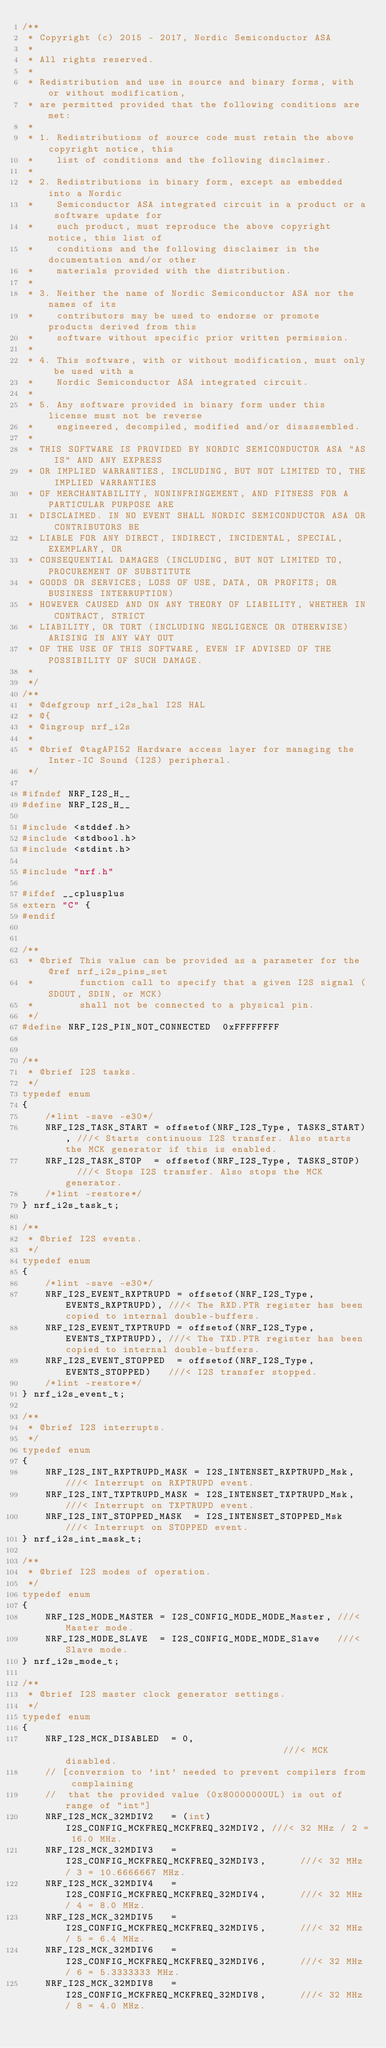Convert code to text. <code><loc_0><loc_0><loc_500><loc_500><_C_>/**
 * Copyright (c) 2015 - 2017, Nordic Semiconductor ASA
 *
 * All rights reserved.
 *
 * Redistribution and use in source and binary forms, with or without modification,
 * are permitted provided that the following conditions are met:
 *
 * 1. Redistributions of source code must retain the above copyright notice, this
 *    list of conditions and the following disclaimer.
 *
 * 2. Redistributions in binary form, except as embedded into a Nordic
 *    Semiconductor ASA integrated circuit in a product or a software update for
 *    such product, must reproduce the above copyright notice, this list of
 *    conditions and the following disclaimer in the documentation and/or other
 *    materials provided with the distribution.
 *
 * 3. Neither the name of Nordic Semiconductor ASA nor the names of its
 *    contributors may be used to endorse or promote products derived from this
 *    software without specific prior written permission.
 *
 * 4. This software, with or without modification, must only be used with a
 *    Nordic Semiconductor ASA integrated circuit.
 *
 * 5. Any software provided in binary form under this license must not be reverse
 *    engineered, decompiled, modified and/or disassembled.
 *
 * THIS SOFTWARE IS PROVIDED BY NORDIC SEMICONDUCTOR ASA "AS IS" AND ANY EXPRESS
 * OR IMPLIED WARRANTIES, INCLUDING, BUT NOT LIMITED TO, THE IMPLIED WARRANTIES
 * OF MERCHANTABILITY, NONINFRINGEMENT, AND FITNESS FOR A PARTICULAR PURPOSE ARE
 * DISCLAIMED. IN NO EVENT SHALL NORDIC SEMICONDUCTOR ASA OR CONTRIBUTORS BE
 * LIABLE FOR ANY DIRECT, INDIRECT, INCIDENTAL, SPECIAL, EXEMPLARY, OR
 * CONSEQUENTIAL DAMAGES (INCLUDING, BUT NOT LIMITED TO, PROCUREMENT OF SUBSTITUTE
 * GOODS OR SERVICES; LOSS OF USE, DATA, OR PROFITS; OR BUSINESS INTERRUPTION)
 * HOWEVER CAUSED AND ON ANY THEORY OF LIABILITY, WHETHER IN CONTRACT, STRICT
 * LIABILITY, OR TORT (INCLUDING NEGLIGENCE OR OTHERWISE) ARISING IN ANY WAY OUT
 * OF THE USE OF THIS SOFTWARE, EVEN IF ADVISED OF THE POSSIBILITY OF SUCH DAMAGE.
 *
 */
/**
 * @defgroup nrf_i2s_hal I2S HAL
 * @{
 * @ingroup nrf_i2s
 *
 * @brief @tagAPI52 Hardware access layer for managing the Inter-IC Sound (I2S) peripheral.
 */

#ifndef NRF_I2S_H__
#define NRF_I2S_H__

#include <stddef.h>
#include <stdbool.h>
#include <stdint.h>

#include "nrf.h"

#ifdef __cplusplus
extern "C" {
#endif


/**
 * @brief This value can be provided as a parameter for the @ref nrf_i2s_pins_set
 *        function call to specify that a given I2S signal (SDOUT, SDIN, or MCK)
 *        shall not be connected to a physical pin.
 */
#define NRF_I2S_PIN_NOT_CONNECTED  0xFFFFFFFF


/**
 * @brief I2S tasks.
 */
typedef enum
{
    /*lint -save -e30*/
    NRF_I2S_TASK_START = offsetof(NRF_I2S_Type, TASKS_START), ///< Starts continuous I2S transfer. Also starts the MCK generator if this is enabled.
    NRF_I2S_TASK_STOP  = offsetof(NRF_I2S_Type, TASKS_STOP)   ///< Stops I2S transfer. Also stops the MCK generator.
    /*lint -restore*/
} nrf_i2s_task_t;

/**
 * @brief I2S events.
 */
typedef enum
{
    /*lint -save -e30*/
    NRF_I2S_EVENT_RXPTRUPD = offsetof(NRF_I2S_Type, EVENTS_RXPTRUPD), ///< The RXD.PTR register has been copied to internal double-buffers.
    NRF_I2S_EVENT_TXPTRUPD = offsetof(NRF_I2S_Type, EVENTS_TXPTRUPD), ///< The TXD.PTR register has been copied to internal double-buffers.
    NRF_I2S_EVENT_STOPPED  = offsetof(NRF_I2S_Type, EVENTS_STOPPED)   ///< I2S transfer stopped.
    /*lint -restore*/
} nrf_i2s_event_t;

/**
 * @brief I2S interrupts.
 */
typedef enum
{
    NRF_I2S_INT_RXPTRUPD_MASK = I2S_INTENSET_RXPTRUPD_Msk, ///< Interrupt on RXPTRUPD event.
    NRF_I2S_INT_TXPTRUPD_MASK = I2S_INTENSET_TXPTRUPD_Msk, ///< Interrupt on TXPTRUPD event.
    NRF_I2S_INT_STOPPED_MASK  = I2S_INTENSET_STOPPED_Msk   ///< Interrupt on STOPPED event.
} nrf_i2s_int_mask_t;

/**
 * @brief I2S modes of operation.
 */
typedef enum
{
    NRF_I2S_MODE_MASTER = I2S_CONFIG_MODE_MODE_Master, ///< Master mode.
    NRF_I2S_MODE_SLAVE  = I2S_CONFIG_MODE_MODE_Slave   ///< Slave mode.
} nrf_i2s_mode_t;

/**
 * @brief I2S master clock generator settings.
 */
typedef enum
{
    NRF_I2S_MCK_DISABLED  = 0,                                       ///< MCK disabled.
    // [conversion to 'int' needed to prevent compilers from complaining
    //  that the provided value (0x80000000UL) is out of range of "int"]
    NRF_I2S_MCK_32MDIV2   = (int)I2S_CONFIG_MCKFREQ_MCKFREQ_32MDIV2, ///< 32 MHz / 2 = 16.0 MHz.
    NRF_I2S_MCK_32MDIV3   = I2S_CONFIG_MCKFREQ_MCKFREQ_32MDIV3,      ///< 32 MHz / 3 = 10.6666667 MHz.
    NRF_I2S_MCK_32MDIV4   = I2S_CONFIG_MCKFREQ_MCKFREQ_32MDIV4,      ///< 32 MHz / 4 = 8.0 MHz.
    NRF_I2S_MCK_32MDIV5   = I2S_CONFIG_MCKFREQ_MCKFREQ_32MDIV5,      ///< 32 MHz / 5 = 6.4 MHz.
    NRF_I2S_MCK_32MDIV6   = I2S_CONFIG_MCKFREQ_MCKFREQ_32MDIV6,      ///< 32 MHz / 6 = 5.3333333 MHz.
    NRF_I2S_MCK_32MDIV8   = I2S_CONFIG_MCKFREQ_MCKFREQ_32MDIV8,      ///< 32 MHz / 8 = 4.0 MHz.</code> 